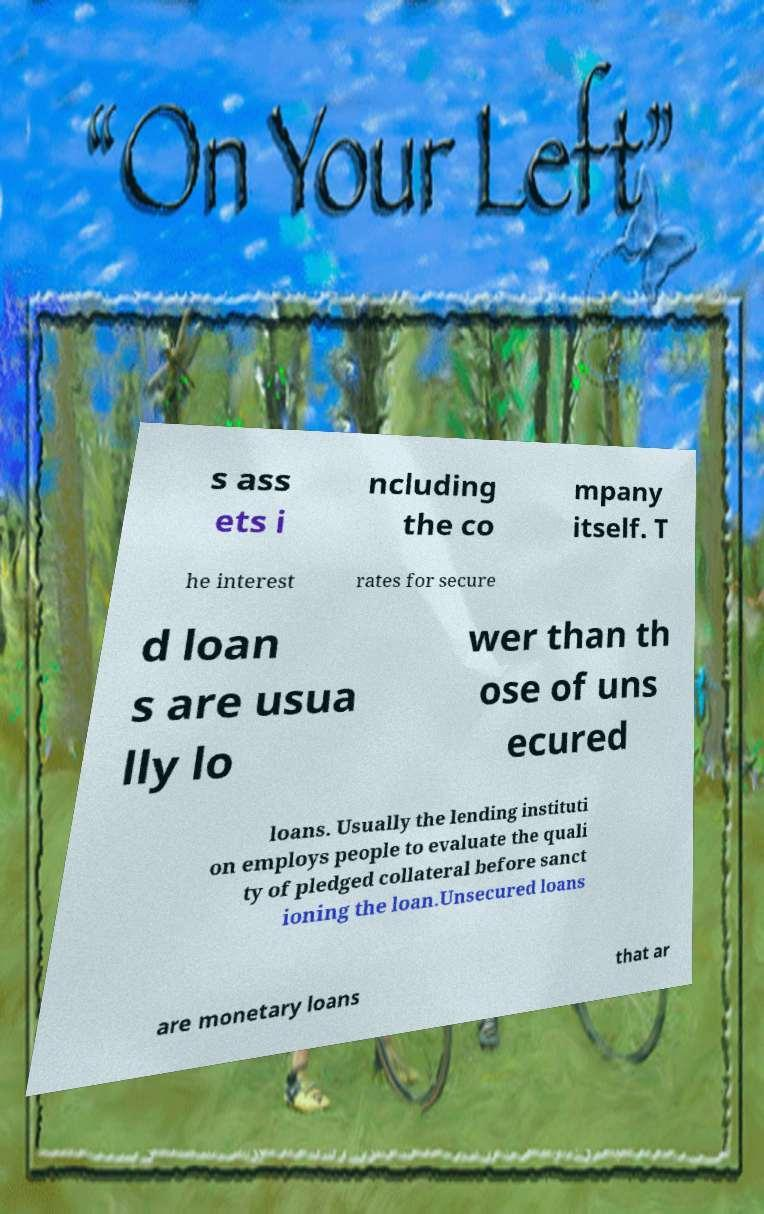There's text embedded in this image that I need extracted. Can you transcribe it verbatim? s ass ets i ncluding the co mpany itself. T he interest rates for secure d loan s are usua lly lo wer than th ose of uns ecured loans. Usually the lending instituti on employs people to evaluate the quali ty of pledged collateral before sanct ioning the loan.Unsecured loans are monetary loans that ar 